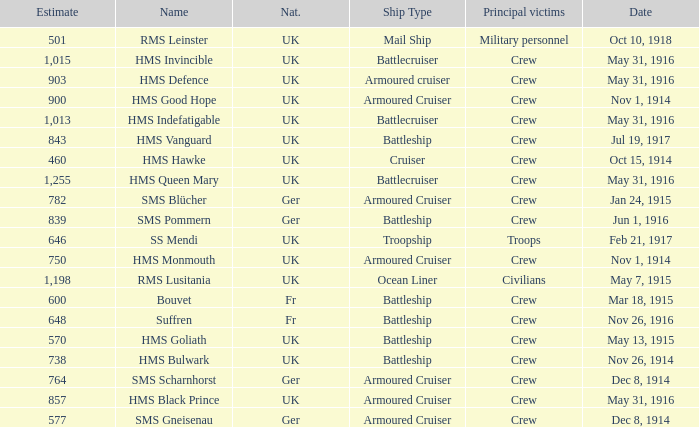What is the appellation of the battleship participating in the skirmish on may 13, 1915? HMS Goliath. 